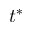<formula> <loc_0><loc_0><loc_500><loc_500>t ^ { * }</formula> 